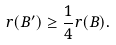<formula> <loc_0><loc_0><loc_500><loc_500>r ( B ^ { \prime } ) \geq \frac { 1 } { 4 } r ( B ) .</formula> 